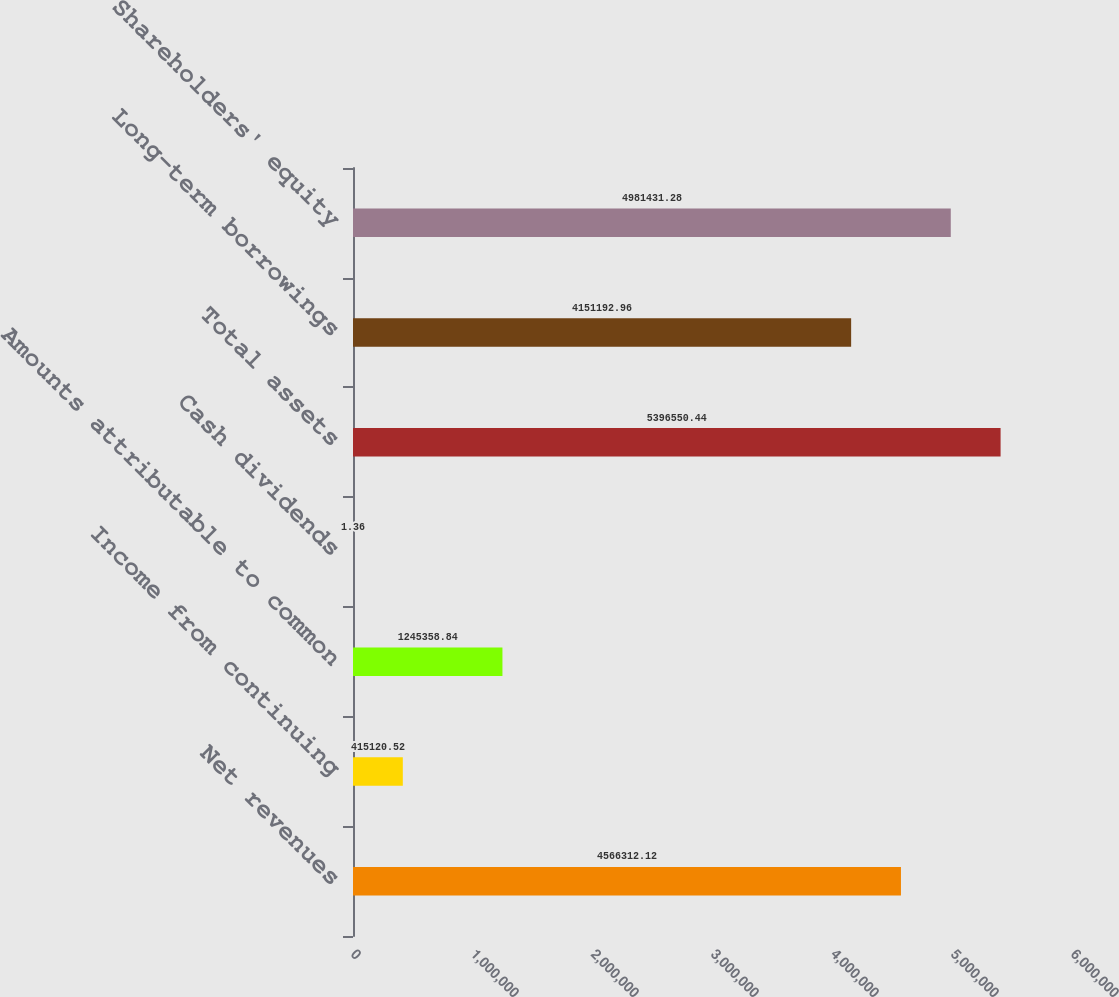Convert chart. <chart><loc_0><loc_0><loc_500><loc_500><bar_chart><fcel>Net revenues<fcel>Income from continuing<fcel>Amounts attributable to common<fcel>Cash dividends<fcel>Total assets<fcel>Long-term borrowings<fcel>Shareholders' equity<nl><fcel>4.56631e+06<fcel>415121<fcel>1.24536e+06<fcel>1.36<fcel>5.39655e+06<fcel>4.15119e+06<fcel>4.98143e+06<nl></chart> 